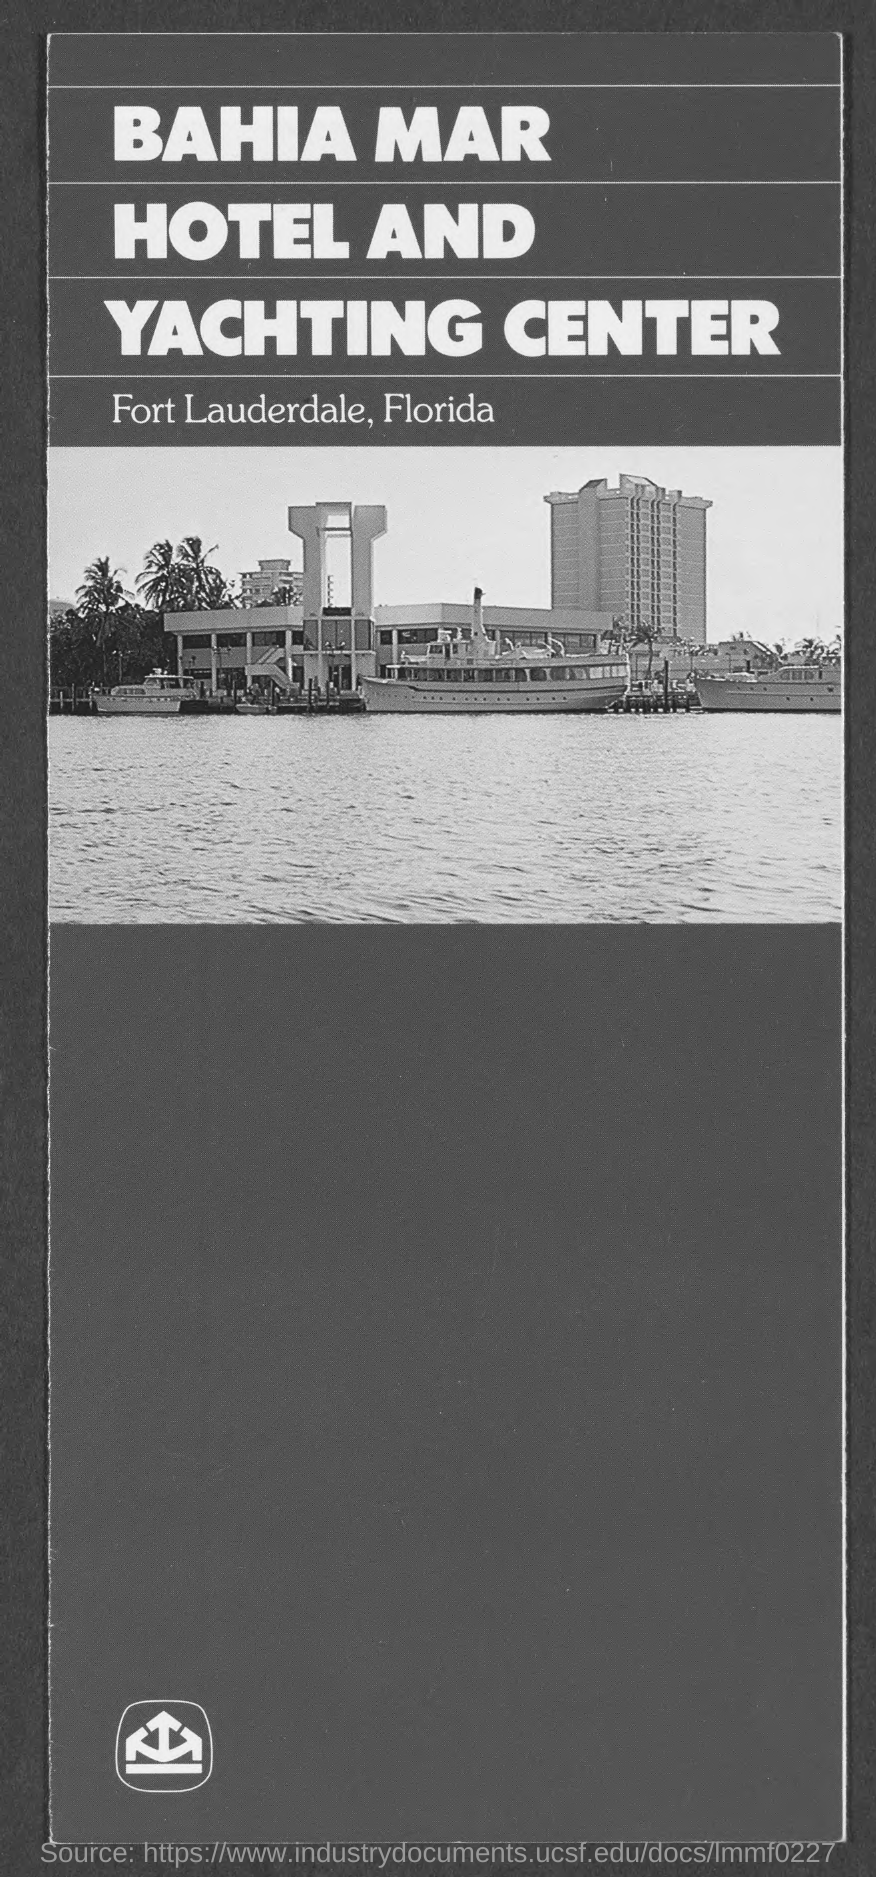What is shown in the picture?
Offer a terse response. BAHIA MAR HOTEL AND YACHTING CENTER. In which city is "BAHIA MAR HOTEL AND YACHTING CENTER" located?
Ensure brevity in your answer.  Fort lauderdale. In which state is "BAHIA MAR HOTEL AND YACHTING CENTER" located?
Make the answer very short. Florida. Where is ""BAHIA MAR HOTEL AND YACHTING CENTER" located?
Make the answer very short. Fort lauderdale, florida. 